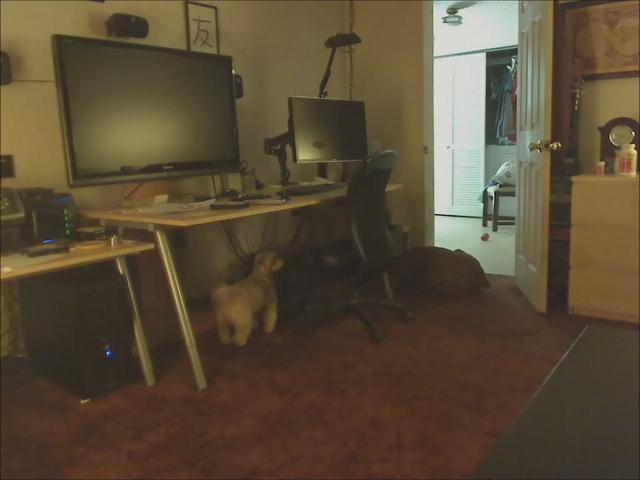What has a triangle shape in the room?
Keep it brief. Table legs. What material are the floors made of?
Keep it brief. Carpet. Does the room have carpet?
Write a very short answer. Yes. Is there a wine glass on the stand?
Quick response, please. No. How many chairs are in this room?
Write a very short answer. 1. How many chairs?
Keep it brief. 1. What color is the chair?
Keep it brief. Black. Is the dog standing beneath the desk?
Write a very short answer. Yes. What pattern is shown on the book bag?
Quick response, please. Solid. What color is the carpet?
Concise answer only. Brown. Does it seem that there is something grimy about this picture?
Concise answer only. Yes. What kind of dog is on the floor?
Answer briefly. Poodle. Is the TV turned on?
Concise answer only. No. What is the floor made of?
Be succinct. Carpet. What are the walls made of?
Answer briefly. Drywall. What is the floor covered with?
Quick response, please. Carpet. Is the computer monitor on?
Be succinct. No. What room in the house is this?
Quick response, please. Bedroom. Is the TV on?
Quick response, please. No. What is the far left wall made of?
Be succinct. Drywall. How many screens are in the room?
Concise answer only. 2. Is the screen turn on?
Short answer required. No. What is inside the wall in the background?
Give a very brief answer. Closet. Is the dog looking at the camera?
Concise answer only. No. Is there carpet or tile in this apartment?
Concise answer only. Carpet. Is the tv on?
Write a very short answer. No. What color is the table?
Short answer required. Tan. Are the floors shiny?
Give a very brief answer. No. How many pianos are shown?
Answer briefly. 0. 